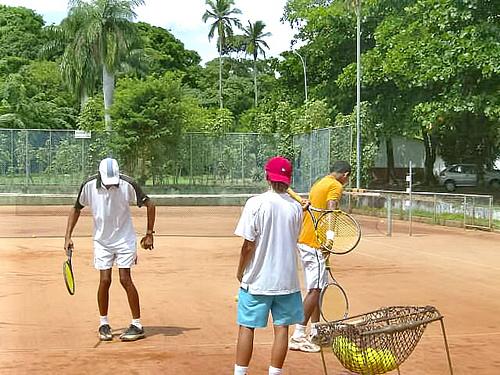What game are they playing?
Be succinct. Tennis. What equipment are the men holding?
Be succinct. Rackets. Where are the tennis balls?
Quick response, please. In basket. 